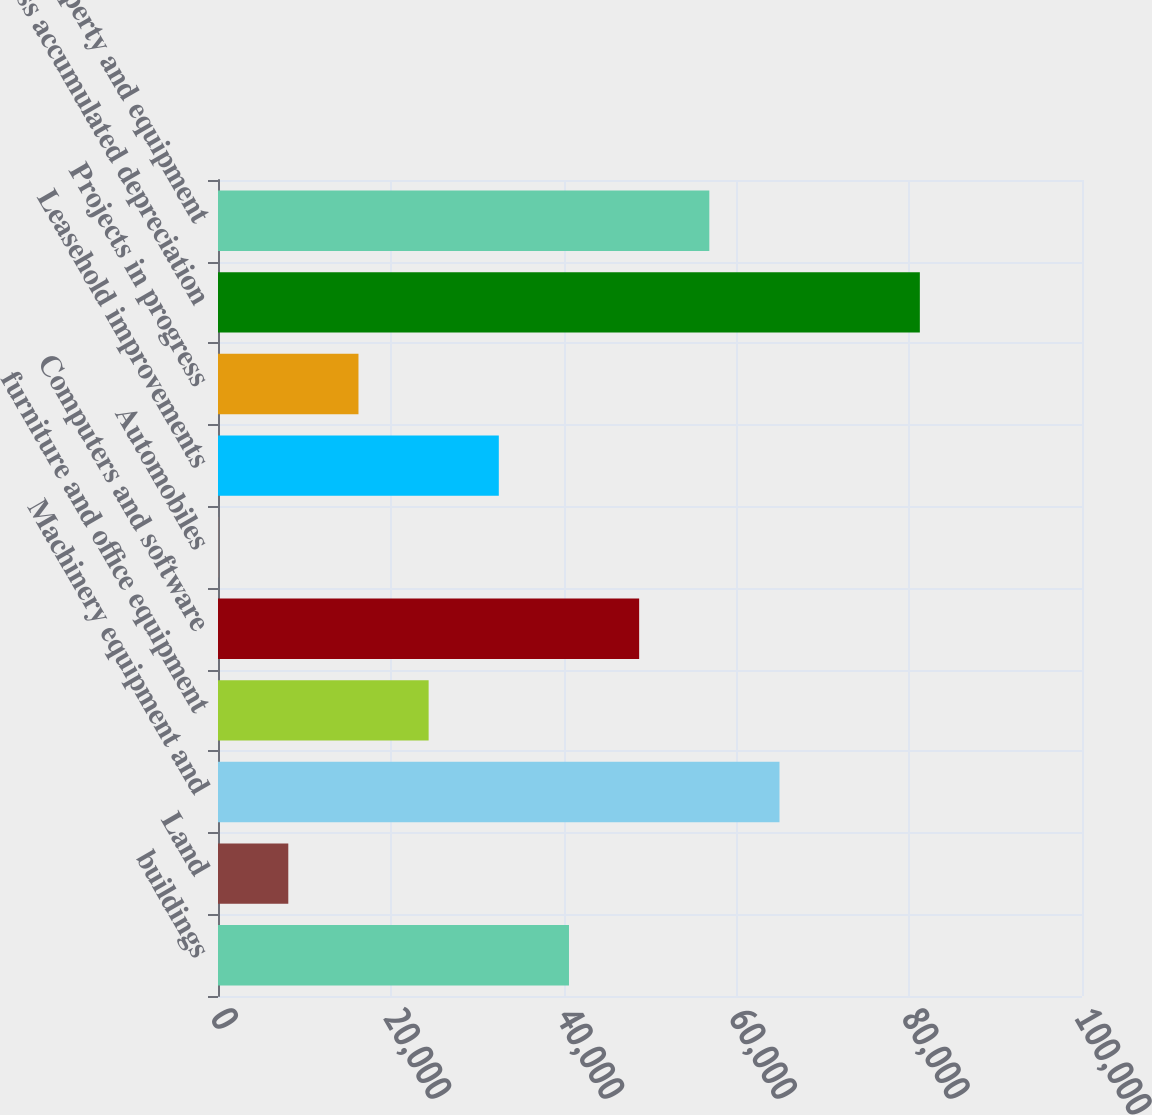Convert chart. <chart><loc_0><loc_0><loc_500><loc_500><bar_chart><fcel>buildings<fcel>Land<fcel>Machinery equipment and<fcel>furniture and office equipment<fcel>Computers and software<fcel>Automobiles<fcel>Leasehold improvements<fcel>Projects in progress<fcel>Less accumulated depreciation<fcel>Net property and equipment<nl><fcel>40623<fcel>8135.8<fcel>64988.4<fcel>24379.4<fcel>48744.8<fcel>14<fcel>32501.2<fcel>16257.6<fcel>81232<fcel>56866.6<nl></chart> 